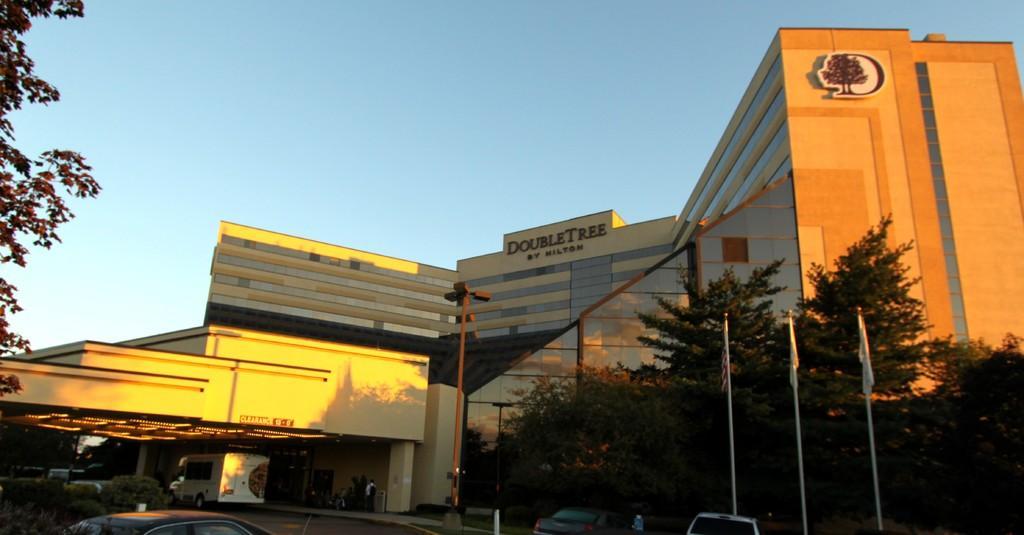Describe this image in one or two sentences. In the foreground of this picture, there is a building, trees, vehicles and poles. On the top, there is the sky. 